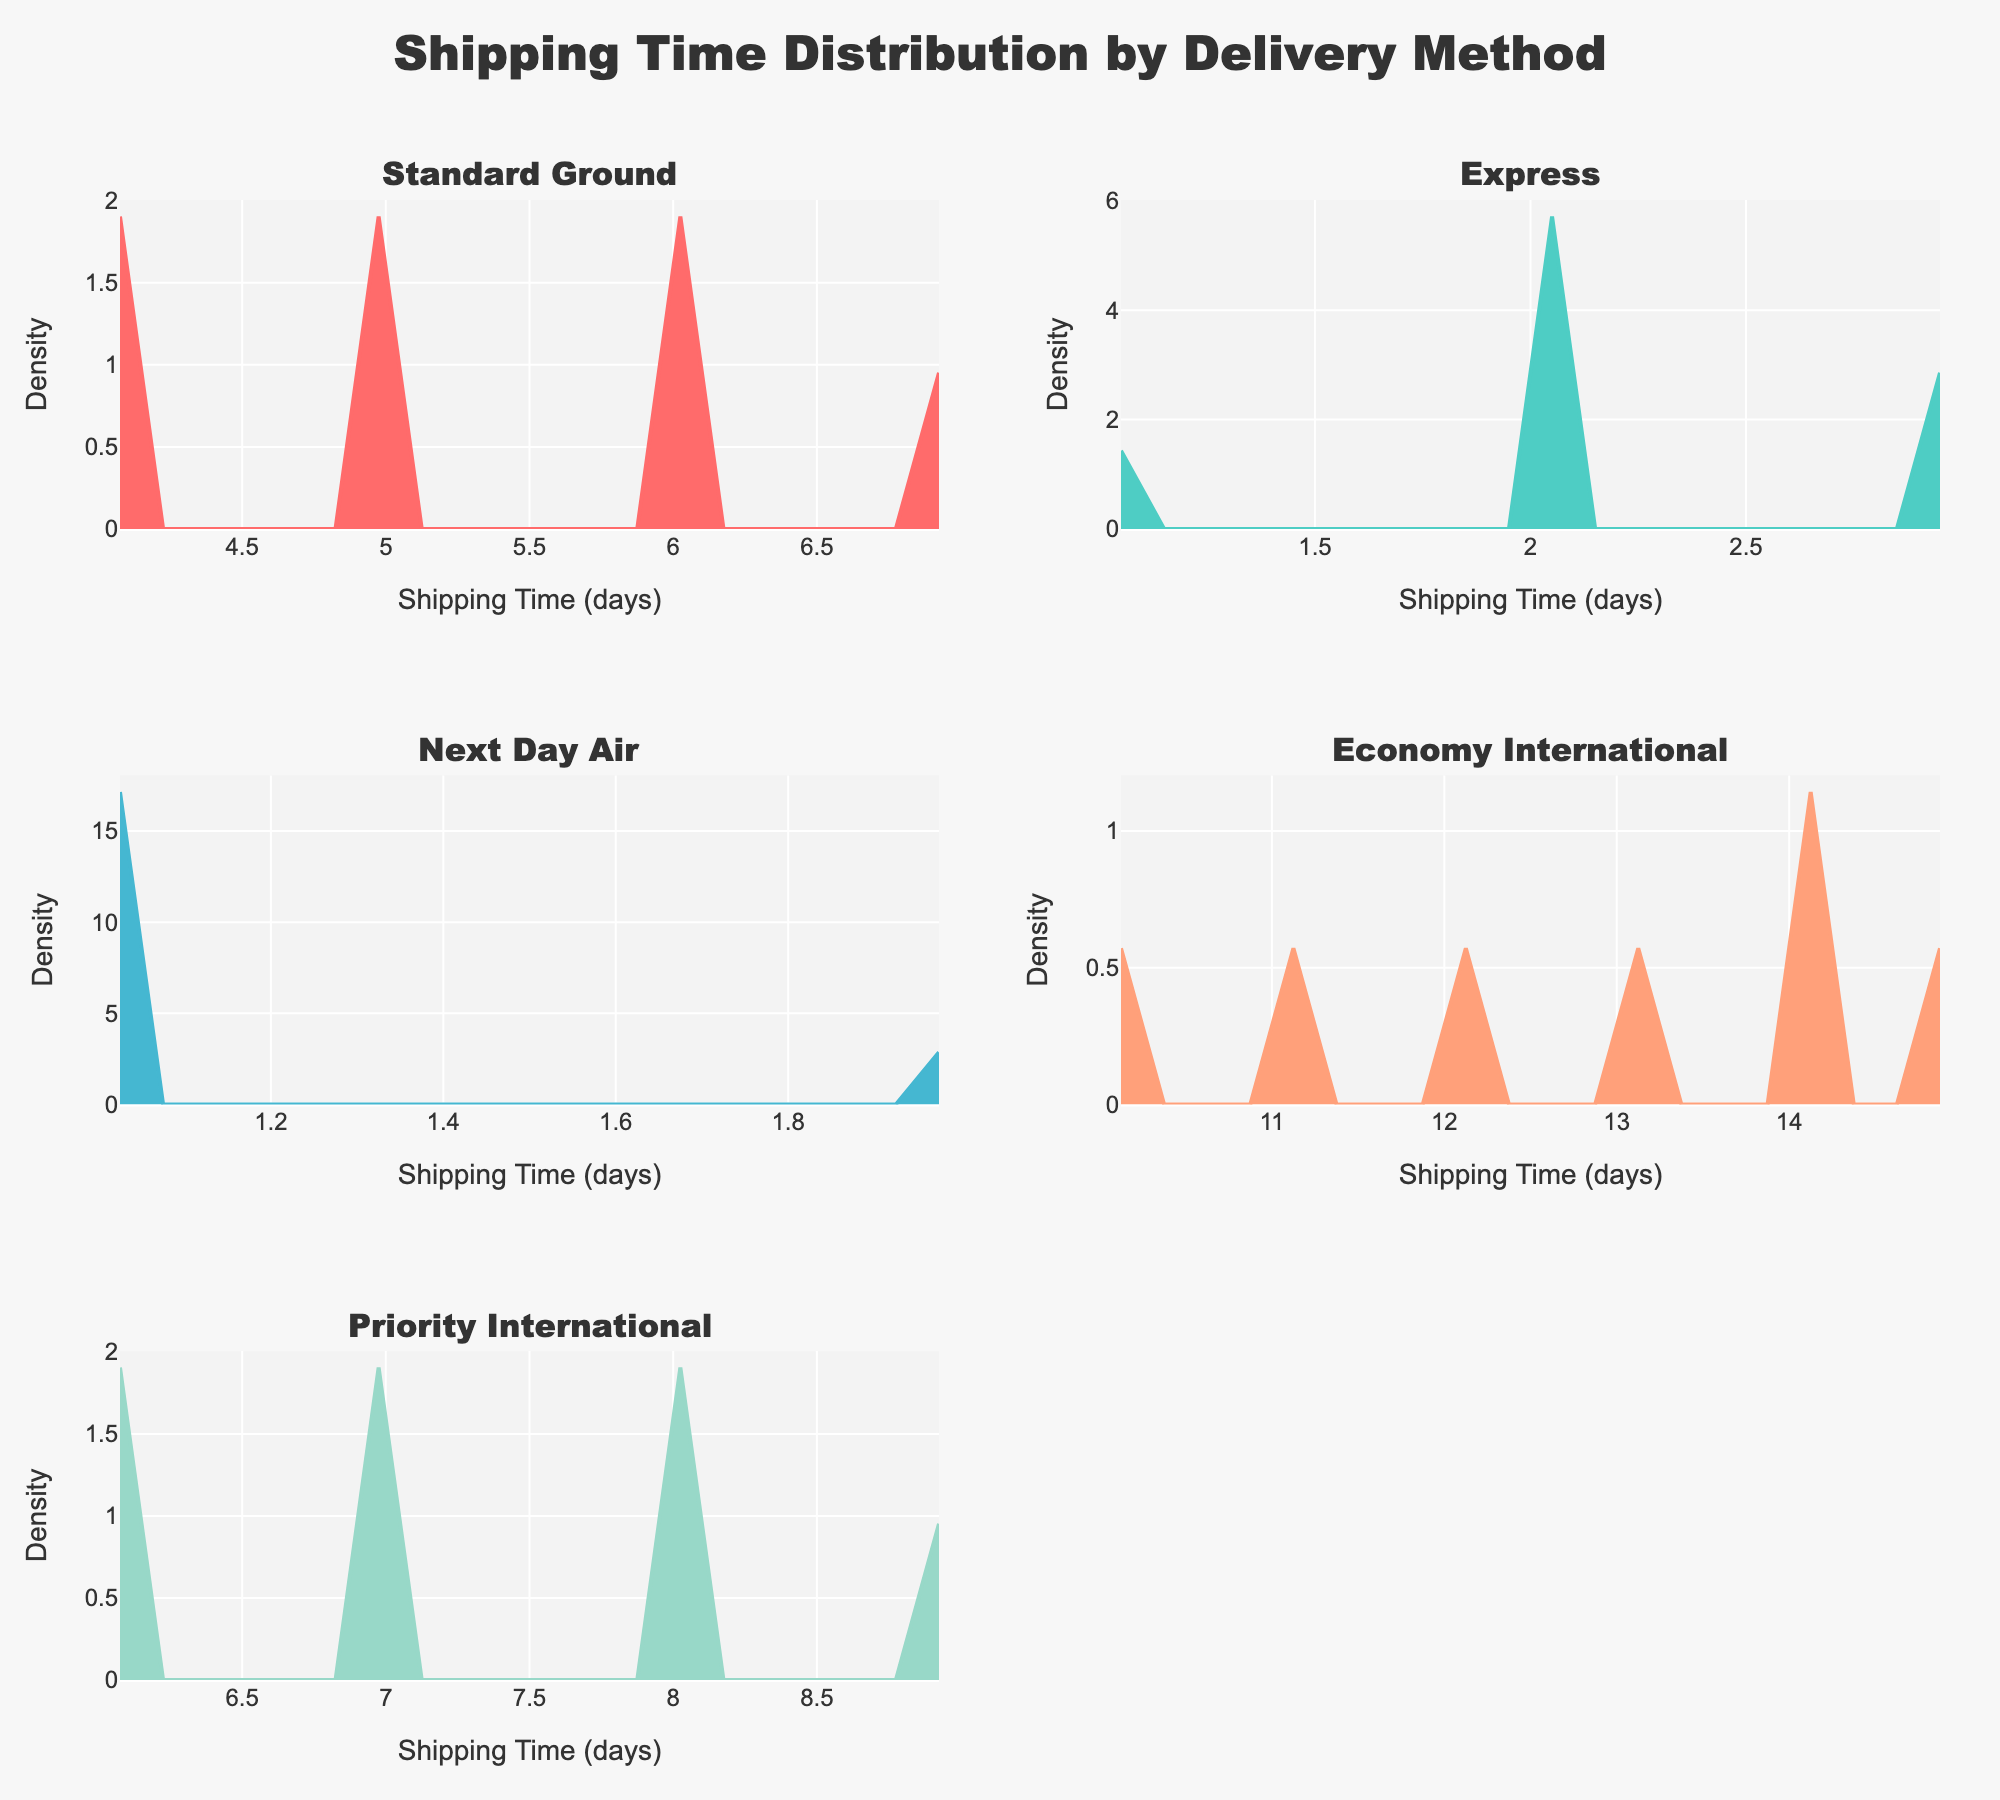What's the title of the plot? The title of the plot is displayed at the top center of the figure, and it is "Shipping Time Distribution by Delivery Method".
Answer: Shipping Time Distribution by Delivery Method How many total subplots are there? The figure is divided into subplots arranged in a 3x2 grid. Each row contains 2 plots and there are 3 rows, making a total of 6 subplots.
Answer: 6 Which delivery method has the most days required for shipping? Looking at the names of the delivery methods, "Economy International" is the one with the highest shipping times, as it peaks around 12-15 days.
Answer: Economy International Which delivery method has the shortest shipping time? The "Next Day Air" method shows the shortest shipping times, with peaks around 1-2 days.
Answer: Next Day Air Do all delivery methods have the same distribution shape? By examining the density curves of each subplot, it is clear that the shapes of the distributions vary between delivery methods. Some methods have a single peak, while others have different forms of distribution.
Answer: No What is the shipping time for which "Priority International" shows the highest density? The subplot for "Priority International" shows the highest density around 6-7 days of shipping time.
Answer: 6-7 days Which delivery method has the widest range of shipping times? "Economy International" displays the widest range of shipping times, spanning roughly from 10 to 15 days.
Answer: Economy International Which delivery method appears to have the most variation in shipping times? The "Economy International" dataset shows the most variation in shipping times, as its density plot is spread out across a broader range.
Answer: Economy International Are any of the delivery methods' density plots similar? Comparing the density plots, "Express" and "Next Day Air" have similar shapes as both show relatively narrow peaks around their shipping time ranges, though they peak at different times.
Answer: Yes, Express and Next Day Air 